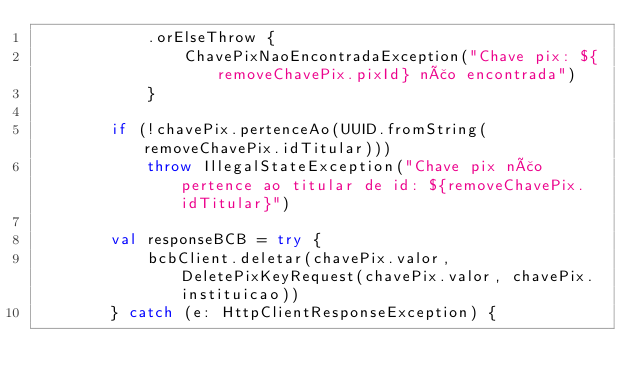<code> <loc_0><loc_0><loc_500><loc_500><_Kotlin_>            .orElseThrow {
                ChavePixNaoEncontradaException("Chave pix: ${removeChavePix.pixId} não encontrada")
            }

        if (!chavePix.pertenceAo(UUID.fromString(removeChavePix.idTitular)))
            throw IllegalStateException("Chave pix não pertence ao titular de id: ${removeChavePix.idTitular}")

        val responseBCB = try {
            bcbClient.deletar(chavePix.valor, DeletePixKeyRequest(chavePix.valor, chavePix.instituicao))
        } catch (e: HttpClientResponseException) {</code> 